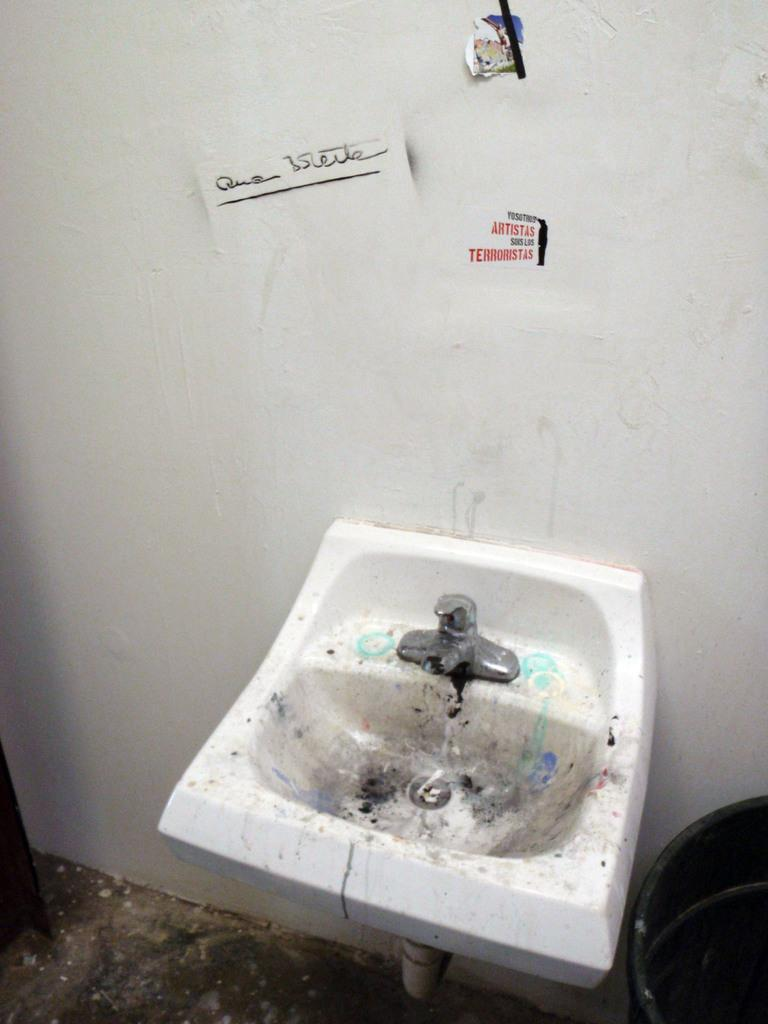What is the main object in the image? There is a wash basin in the image. What is attached to the wash basin? There is a tap in the image. What can be seen on the wall in the image? There are objects on the wall in the image. What color is the wall in the image? The wall is white in color. What type of shame can be seen on the wall in the image? There is no shame present in the image; it is a wash basin with a tap and objects on the wall. How many members are in the group depicted in the image? There is no group of people present in the image; it is a wash basin with a tap and objects on the wall. 